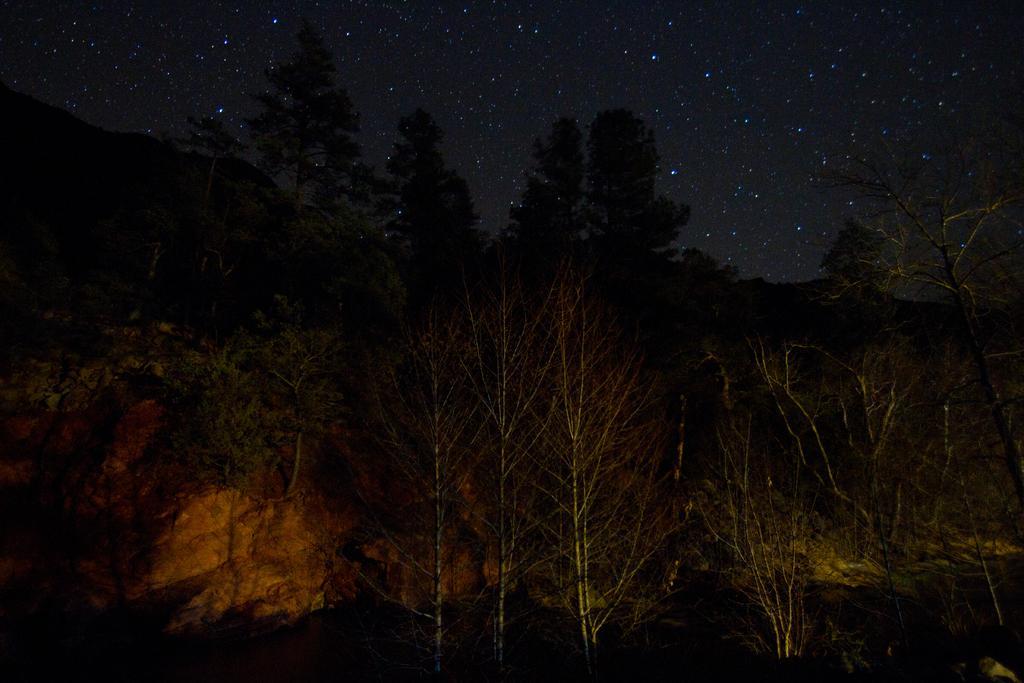How would you summarize this image in a sentence or two? In this image we can see a group of trees, the rocks, stars and the sky. 